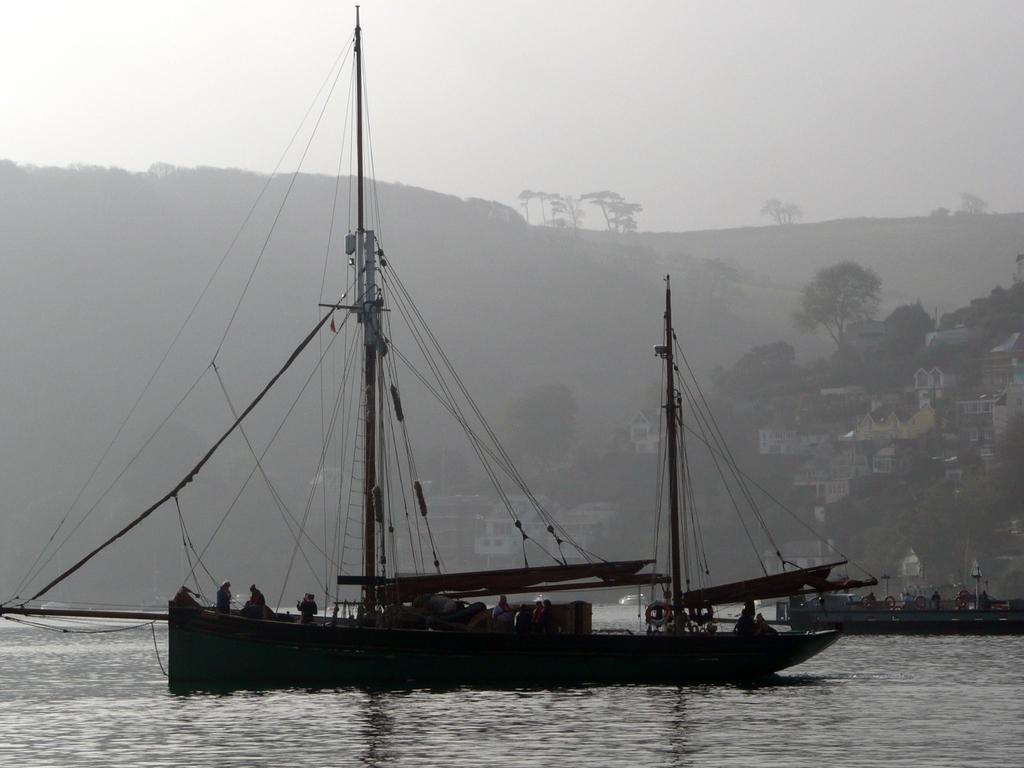What is the main feature of the image? There is water in the image. What is floating on the surface of the water? There is a boat on the surface of the water. What can be seen in the distance in the image? There are mountains, buildings, trees, and the sky visible in the background of the image. Which direction is the team moving in the image? There is no team present in the image, so it is not possible to determine the direction in which they might be moving. 